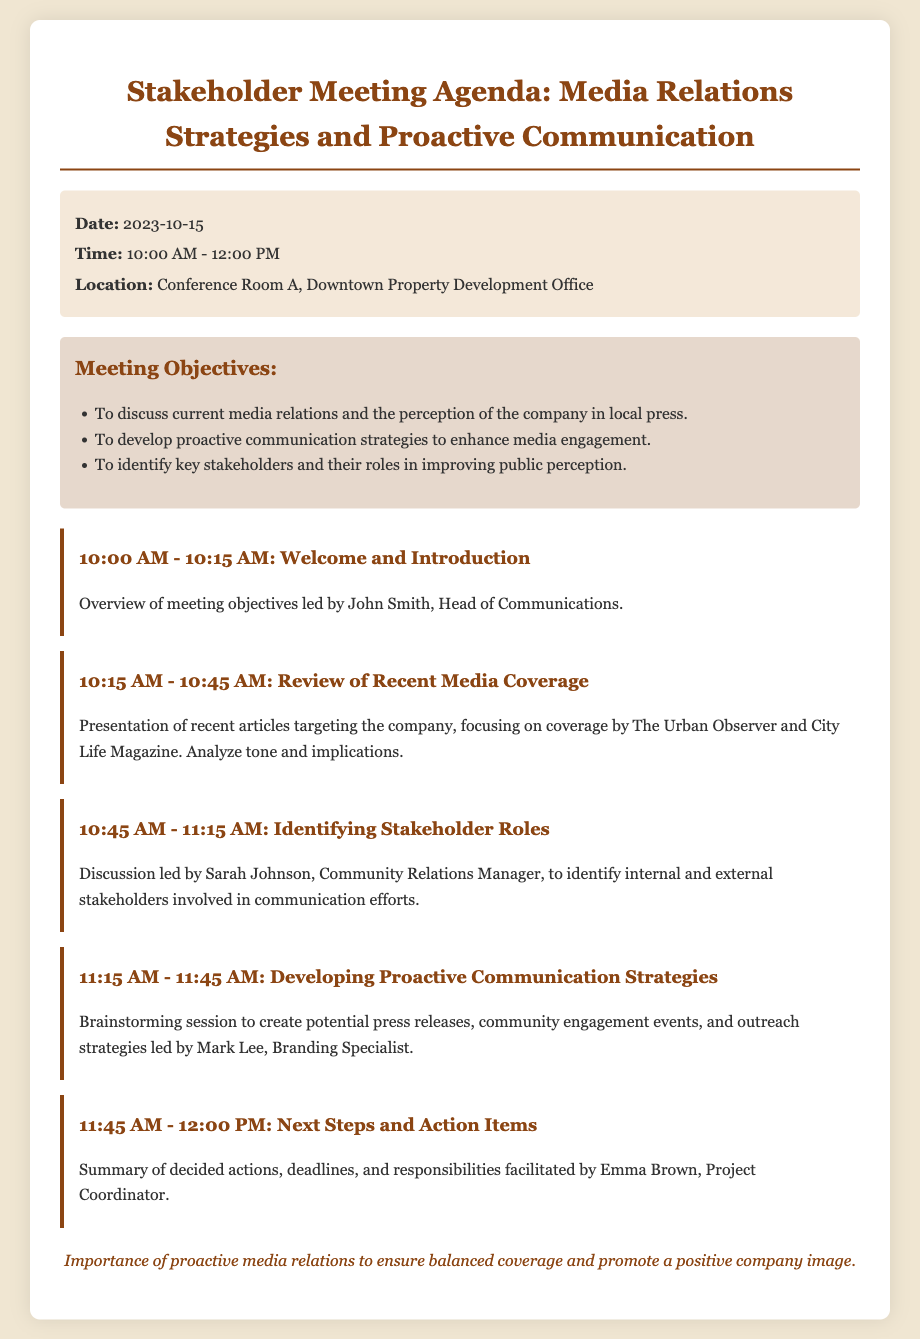What is the date of the meeting? The meeting date is specified in the document under meeting info.
Answer: 2023-10-15 Who is leading the introduction? The document states that John Smith is responsible for the welcome and introduction.
Answer: John Smith What time does the review of recent media coverage start? The agenda lists the time for this item.
Answer: 10:15 AM What is the primary focus of the second agenda item? This agenda item discusses the analysis of recent articles targeting the company.
Answer: Recent articles targeting the company Who will lead the discussion on identifying stakeholder roles? The document notes that Sarah Johnson will lead this discussion.
Answer: Sarah Johnson What is the final agenda item about? The last item summarizes the decided actions, deadlines, and responsibilities.
Answer: Next Steps and Action Items What are the meeting objectives discussing? The objectives involve media relations and enhancing media engagement.
Answer: Media relations and perception in local press What is the location of the meeting? The meeting location is provided in the meeting info section of the document.
Answer: Conference Room A, Downtown Property Development Office 